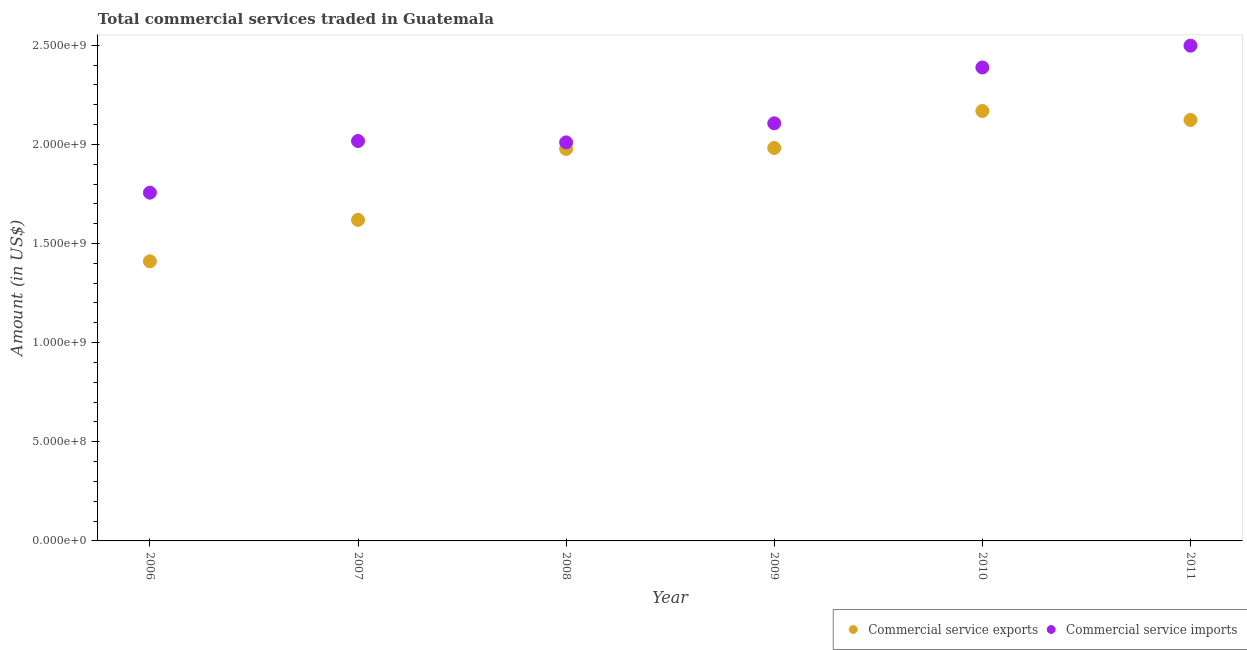How many different coloured dotlines are there?
Your answer should be very brief. 2. Is the number of dotlines equal to the number of legend labels?
Offer a very short reply. Yes. What is the amount of commercial service exports in 2009?
Your response must be concise. 1.98e+09. Across all years, what is the maximum amount of commercial service imports?
Your response must be concise. 2.50e+09. Across all years, what is the minimum amount of commercial service imports?
Give a very brief answer. 1.76e+09. What is the total amount of commercial service imports in the graph?
Your response must be concise. 1.28e+1. What is the difference between the amount of commercial service exports in 2008 and that in 2011?
Keep it short and to the point. -1.46e+08. What is the difference between the amount of commercial service exports in 2011 and the amount of commercial service imports in 2009?
Give a very brief answer. 1.69e+07. What is the average amount of commercial service exports per year?
Ensure brevity in your answer.  1.88e+09. In the year 2006, what is the difference between the amount of commercial service imports and amount of commercial service exports?
Keep it short and to the point. 3.46e+08. In how many years, is the amount of commercial service exports greater than 2000000000 US$?
Your response must be concise. 2. What is the ratio of the amount of commercial service imports in 2007 to that in 2008?
Keep it short and to the point. 1. Is the difference between the amount of commercial service imports in 2009 and 2011 greater than the difference between the amount of commercial service exports in 2009 and 2011?
Ensure brevity in your answer.  No. What is the difference between the highest and the second highest amount of commercial service imports?
Offer a terse response. 1.10e+08. What is the difference between the highest and the lowest amount of commercial service exports?
Make the answer very short. 7.58e+08. Is the sum of the amount of commercial service exports in 2006 and 2008 greater than the maximum amount of commercial service imports across all years?
Your response must be concise. Yes. Is the amount of commercial service exports strictly greater than the amount of commercial service imports over the years?
Give a very brief answer. No. Is the amount of commercial service exports strictly less than the amount of commercial service imports over the years?
Offer a very short reply. Yes. What is the difference between two consecutive major ticks on the Y-axis?
Your response must be concise. 5.00e+08. Are the values on the major ticks of Y-axis written in scientific E-notation?
Your response must be concise. Yes. Does the graph contain any zero values?
Provide a short and direct response. No. Does the graph contain grids?
Keep it short and to the point. No. How many legend labels are there?
Offer a very short reply. 2. What is the title of the graph?
Your answer should be very brief. Total commercial services traded in Guatemala. What is the Amount (in US$) in Commercial service exports in 2006?
Keep it short and to the point. 1.41e+09. What is the Amount (in US$) in Commercial service imports in 2006?
Ensure brevity in your answer.  1.76e+09. What is the Amount (in US$) of Commercial service exports in 2007?
Ensure brevity in your answer.  1.62e+09. What is the Amount (in US$) of Commercial service imports in 2007?
Keep it short and to the point. 2.02e+09. What is the Amount (in US$) in Commercial service exports in 2008?
Offer a very short reply. 1.98e+09. What is the Amount (in US$) of Commercial service imports in 2008?
Your answer should be very brief. 2.01e+09. What is the Amount (in US$) of Commercial service exports in 2009?
Make the answer very short. 1.98e+09. What is the Amount (in US$) in Commercial service imports in 2009?
Give a very brief answer. 2.11e+09. What is the Amount (in US$) of Commercial service exports in 2010?
Ensure brevity in your answer.  2.17e+09. What is the Amount (in US$) of Commercial service imports in 2010?
Give a very brief answer. 2.39e+09. What is the Amount (in US$) in Commercial service exports in 2011?
Ensure brevity in your answer.  2.12e+09. What is the Amount (in US$) in Commercial service imports in 2011?
Your answer should be very brief. 2.50e+09. Across all years, what is the maximum Amount (in US$) in Commercial service exports?
Provide a short and direct response. 2.17e+09. Across all years, what is the maximum Amount (in US$) of Commercial service imports?
Offer a terse response. 2.50e+09. Across all years, what is the minimum Amount (in US$) in Commercial service exports?
Offer a very short reply. 1.41e+09. Across all years, what is the minimum Amount (in US$) of Commercial service imports?
Provide a succinct answer. 1.76e+09. What is the total Amount (in US$) of Commercial service exports in the graph?
Offer a terse response. 1.13e+1. What is the total Amount (in US$) of Commercial service imports in the graph?
Keep it short and to the point. 1.28e+1. What is the difference between the Amount (in US$) in Commercial service exports in 2006 and that in 2007?
Your answer should be very brief. -2.09e+08. What is the difference between the Amount (in US$) in Commercial service imports in 2006 and that in 2007?
Offer a very short reply. -2.61e+08. What is the difference between the Amount (in US$) of Commercial service exports in 2006 and that in 2008?
Provide a short and direct response. -5.67e+08. What is the difference between the Amount (in US$) of Commercial service imports in 2006 and that in 2008?
Give a very brief answer. -2.54e+08. What is the difference between the Amount (in US$) in Commercial service exports in 2006 and that in 2009?
Keep it short and to the point. -5.72e+08. What is the difference between the Amount (in US$) in Commercial service imports in 2006 and that in 2009?
Provide a succinct answer. -3.50e+08. What is the difference between the Amount (in US$) in Commercial service exports in 2006 and that in 2010?
Offer a terse response. -7.58e+08. What is the difference between the Amount (in US$) of Commercial service imports in 2006 and that in 2010?
Give a very brief answer. -6.31e+08. What is the difference between the Amount (in US$) of Commercial service exports in 2006 and that in 2011?
Ensure brevity in your answer.  -7.13e+08. What is the difference between the Amount (in US$) in Commercial service imports in 2006 and that in 2011?
Provide a succinct answer. -7.41e+08. What is the difference between the Amount (in US$) of Commercial service exports in 2007 and that in 2008?
Give a very brief answer. -3.58e+08. What is the difference between the Amount (in US$) in Commercial service imports in 2007 and that in 2008?
Your answer should be compact. 6.97e+06. What is the difference between the Amount (in US$) of Commercial service exports in 2007 and that in 2009?
Your answer should be compact. -3.62e+08. What is the difference between the Amount (in US$) of Commercial service imports in 2007 and that in 2009?
Provide a succinct answer. -8.92e+07. What is the difference between the Amount (in US$) in Commercial service exports in 2007 and that in 2010?
Make the answer very short. -5.49e+08. What is the difference between the Amount (in US$) of Commercial service imports in 2007 and that in 2010?
Provide a succinct answer. -3.71e+08. What is the difference between the Amount (in US$) in Commercial service exports in 2007 and that in 2011?
Your response must be concise. -5.04e+08. What is the difference between the Amount (in US$) of Commercial service imports in 2007 and that in 2011?
Your answer should be compact. -4.81e+08. What is the difference between the Amount (in US$) in Commercial service exports in 2008 and that in 2009?
Keep it short and to the point. -4.57e+06. What is the difference between the Amount (in US$) of Commercial service imports in 2008 and that in 2009?
Your answer should be very brief. -9.61e+07. What is the difference between the Amount (in US$) in Commercial service exports in 2008 and that in 2010?
Your response must be concise. -1.91e+08. What is the difference between the Amount (in US$) in Commercial service imports in 2008 and that in 2010?
Keep it short and to the point. -3.78e+08. What is the difference between the Amount (in US$) in Commercial service exports in 2008 and that in 2011?
Keep it short and to the point. -1.46e+08. What is the difference between the Amount (in US$) of Commercial service imports in 2008 and that in 2011?
Provide a short and direct response. -4.88e+08. What is the difference between the Amount (in US$) of Commercial service exports in 2009 and that in 2010?
Provide a succinct answer. -1.87e+08. What is the difference between the Amount (in US$) in Commercial service imports in 2009 and that in 2010?
Offer a terse response. -2.82e+08. What is the difference between the Amount (in US$) in Commercial service exports in 2009 and that in 2011?
Your answer should be very brief. -1.41e+08. What is the difference between the Amount (in US$) of Commercial service imports in 2009 and that in 2011?
Keep it short and to the point. -3.92e+08. What is the difference between the Amount (in US$) in Commercial service exports in 2010 and that in 2011?
Your response must be concise. 4.53e+07. What is the difference between the Amount (in US$) of Commercial service imports in 2010 and that in 2011?
Give a very brief answer. -1.10e+08. What is the difference between the Amount (in US$) in Commercial service exports in 2006 and the Amount (in US$) in Commercial service imports in 2007?
Keep it short and to the point. -6.07e+08. What is the difference between the Amount (in US$) of Commercial service exports in 2006 and the Amount (in US$) of Commercial service imports in 2008?
Ensure brevity in your answer.  -6.00e+08. What is the difference between the Amount (in US$) of Commercial service exports in 2006 and the Amount (in US$) of Commercial service imports in 2009?
Provide a succinct answer. -6.96e+08. What is the difference between the Amount (in US$) of Commercial service exports in 2006 and the Amount (in US$) of Commercial service imports in 2010?
Your response must be concise. -9.78e+08. What is the difference between the Amount (in US$) of Commercial service exports in 2006 and the Amount (in US$) of Commercial service imports in 2011?
Your answer should be very brief. -1.09e+09. What is the difference between the Amount (in US$) of Commercial service exports in 2007 and the Amount (in US$) of Commercial service imports in 2008?
Your answer should be very brief. -3.91e+08. What is the difference between the Amount (in US$) of Commercial service exports in 2007 and the Amount (in US$) of Commercial service imports in 2009?
Ensure brevity in your answer.  -4.87e+08. What is the difference between the Amount (in US$) of Commercial service exports in 2007 and the Amount (in US$) of Commercial service imports in 2010?
Provide a short and direct response. -7.68e+08. What is the difference between the Amount (in US$) of Commercial service exports in 2007 and the Amount (in US$) of Commercial service imports in 2011?
Keep it short and to the point. -8.79e+08. What is the difference between the Amount (in US$) in Commercial service exports in 2008 and the Amount (in US$) in Commercial service imports in 2009?
Give a very brief answer. -1.29e+08. What is the difference between the Amount (in US$) of Commercial service exports in 2008 and the Amount (in US$) of Commercial service imports in 2010?
Provide a succinct answer. -4.11e+08. What is the difference between the Amount (in US$) in Commercial service exports in 2008 and the Amount (in US$) in Commercial service imports in 2011?
Your answer should be compact. -5.21e+08. What is the difference between the Amount (in US$) of Commercial service exports in 2009 and the Amount (in US$) of Commercial service imports in 2010?
Your response must be concise. -4.06e+08. What is the difference between the Amount (in US$) in Commercial service exports in 2009 and the Amount (in US$) in Commercial service imports in 2011?
Offer a very short reply. -5.16e+08. What is the difference between the Amount (in US$) of Commercial service exports in 2010 and the Amount (in US$) of Commercial service imports in 2011?
Your response must be concise. -3.30e+08. What is the average Amount (in US$) of Commercial service exports per year?
Your answer should be compact. 1.88e+09. What is the average Amount (in US$) in Commercial service imports per year?
Your response must be concise. 2.13e+09. In the year 2006, what is the difference between the Amount (in US$) in Commercial service exports and Amount (in US$) in Commercial service imports?
Keep it short and to the point. -3.46e+08. In the year 2007, what is the difference between the Amount (in US$) in Commercial service exports and Amount (in US$) in Commercial service imports?
Offer a very short reply. -3.98e+08. In the year 2008, what is the difference between the Amount (in US$) of Commercial service exports and Amount (in US$) of Commercial service imports?
Make the answer very short. -3.29e+07. In the year 2009, what is the difference between the Amount (in US$) of Commercial service exports and Amount (in US$) of Commercial service imports?
Your answer should be compact. -1.24e+08. In the year 2010, what is the difference between the Amount (in US$) of Commercial service exports and Amount (in US$) of Commercial service imports?
Your answer should be very brief. -2.19e+08. In the year 2011, what is the difference between the Amount (in US$) of Commercial service exports and Amount (in US$) of Commercial service imports?
Your answer should be very brief. -3.75e+08. What is the ratio of the Amount (in US$) of Commercial service exports in 2006 to that in 2007?
Your answer should be very brief. 0.87. What is the ratio of the Amount (in US$) of Commercial service imports in 2006 to that in 2007?
Provide a succinct answer. 0.87. What is the ratio of the Amount (in US$) in Commercial service exports in 2006 to that in 2008?
Make the answer very short. 0.71. What is the ratio of the Amount (in US$) of Commercial service imports in 2006 to that in 2008?
Ensure brevity in your answer.  0.87. What is the ratio of the Amount (in US$) in Commercial service exports in 2006 to that in 2009?
Your response must be concise. 0.71. What is the ratio of the Amount (in US$) in Commercial service imports in 2006 to that in 2009?
Provide a succinct answer. 0.83. What is the ratio of the Amount (in US$) in Commercial service exports in 2006 to that in 2010?
Give a very brief answer. 0.65. What is the ratio of the Amount (in US$) of Commercial service imports in 2006 to that in 2010?
Make the answer very short. 0.74. What is the ratio of the Amount (in US$) of Commercial service exports in 2006 to that in 2011?
Offer a very short reply. 0.66. What is the ratio of the Amount (in US$) of Commercial service imports in 2006 to that in 2011?
Keep it short and to the point. 0.7. What is the ratio of the Amount (in US$) in Commercial service exports in 2007 to that in 2008?
Your answer should be very brief. 0.82. What is the ratio of the Amount (in US$) of Commercial service imports in 2007 to that in 2008?
Provide a succinct answer. 1. What is the ratio of the Amount (in US$) in Commercial service exports in 2007 to that in 2009?
Provide a succinct answer. 0.82. What is the ratio of the Amount (in US$) in Commercial service imports in 2007 to that in 2009?
Your answer should be compact. 0.96. What is the ratio of the Amount (in US$) of Commercial service exports in 2007 to that in 2010?
Provide a succinct answer. 0.75. What is the ratio of the Amount (in US$) of Commercial service imports in 2007 to that in 2010?
Provide a short and direct response. 0.84. What is the ratio of the Amount (in US$) of Commercial service exports in 2007 to that in 2011?
Provide a short and direct response. 0.76. What is the ratio of the Amount (in US$) in Commercial service imports in 2007 to that in 2011?
Keep it short and to the point. 0.81. What is the ratio of the Amount (in US$) in Commercial service exports in 2008 to that in 2009?
Provide a short and direct response. 1. What is the ratio of the Amount (in US$) of Commercial service imports in 2008 to that in 2009?
Keep it short and to the point. 0.95. What is the ratio of the Amount (in US$) of Commercial service exports in 2008 to that in 2010?
Keep it short and to the point. 0.91. What is the ratio of the Amount (in US$) in Commercial service imports in 2008 to that in 2010?
Provide a short and direct response. 0.84. What is the ratio of the Amount (in US$) in Commercial service exports in 2008 to that in 2011?
Offer a terse response. 0.93. What is the ratio of the Amount (in US$) in Commercial service imports in 2008 to that in 2011?
Keep it short and to the point. 0.8. What is the ratio of the Amount (in US$) of Commercial service exports in 2009 to that in 2010?
Your answer should be very brief. 0.91. What is the ratio of the Amount (in US$) of Commercial service imports in 2009 to that in 2010?
Make the answer very short. 0.88. What is the ratio of the Amount (in US$) in Commercial service exports in 2009 to that in 2011?
Provide a succinct answer. 0.93. What is the ratio of the Amount (in US$) of Commercial service imports in 2009 to that in 2011?
Your answer should be compact. 0.84. What is the ratio of the Amount (in US$) in Commercial service exports in 2010 to that in 2011?
Ensure brevity in your answer.  1.02. What is the ratio of the Amount (in US$) in Commercial service imports in 2010 to that in 2011?
Give a very brief answer. 0.96. What is the difference between the highest and the second highest Amount (in US$) in Commercial service exports?
Provide a short and direct response. 4.53e+07. What is the difference between the highest and the second highest Amount (in US$) in Commercial service imports?
Make the answer very short. 1.10e+08. What is the difference between the highest and the lowest Amount (in US$) in Commercial service exports?
Offer a very short reply. 7.58e+08. What is the difference between the highest and the lowest Amount (in US$) in Commercial service imports?
Offer a very short reply. 7.41e+08. 